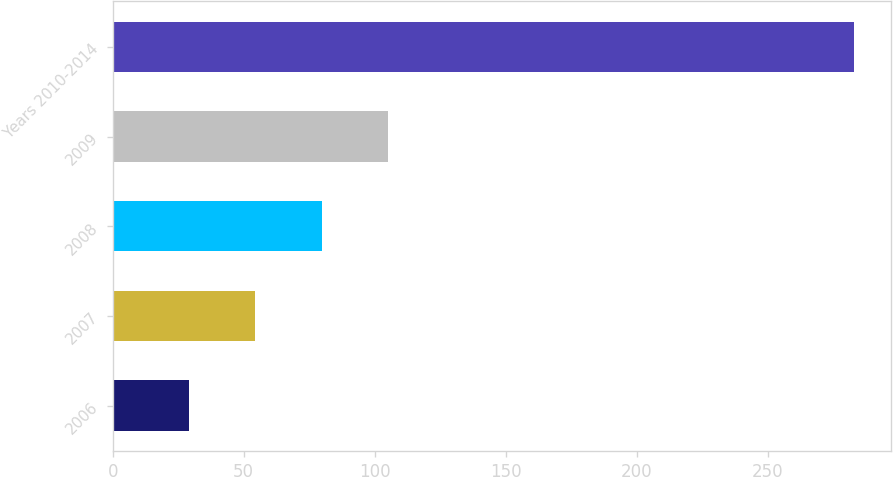<chart> <loc_0><loc_0><loc_500><loc_500><bar_chart><fcel>2006<fcel>2007<fcel>2008<fcel>2009<fcel>Years 2010-2014<nl><fcel>29<fcel>54.4<fcel>79.8<fcel>105.2<fcel>283<nl></chart> 